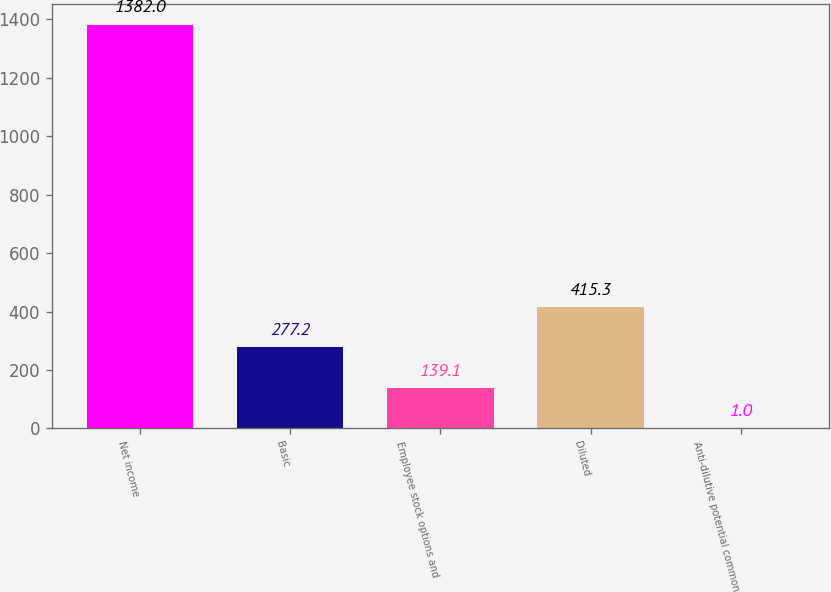<chart> <loc_0><loc_0><loc_500><loc_500><bar_chart><fcel>Net income<fcel>Basic<fcel>Employee stock options and<fcel>Diluted<fcel>Anti-dilutive potential common<nl><fcel>1382<fcel>277.2<fcel>139.1<fcel>415.3<fcel>1<nl></chart> 